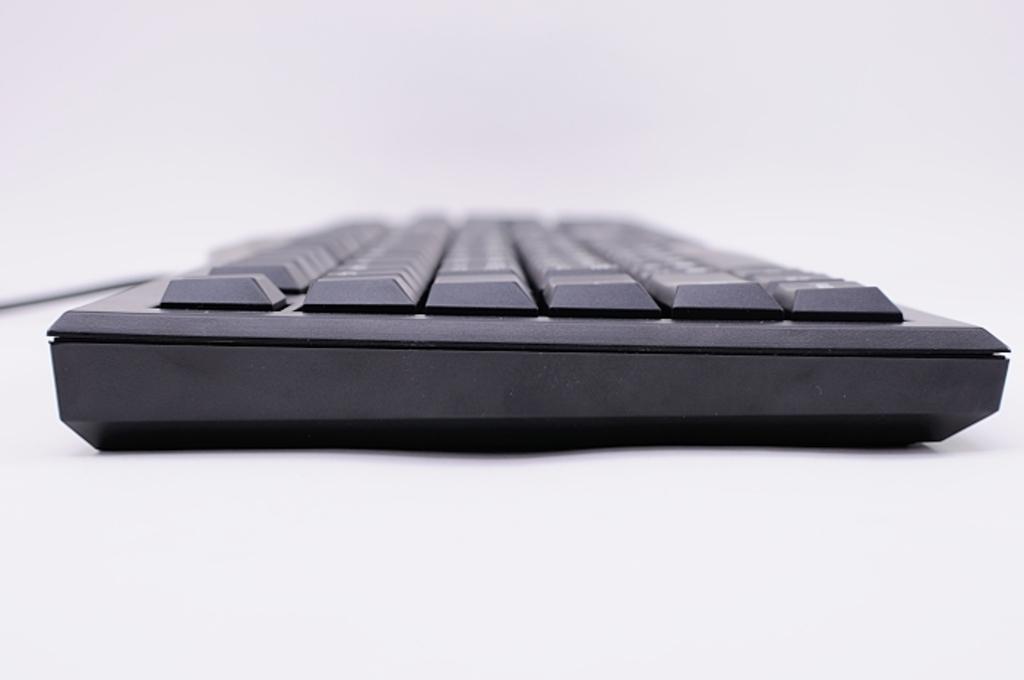Could you give a brief overview of what you see in this image? Here in this picture we can see a black colored keyboard present on the table over there. 